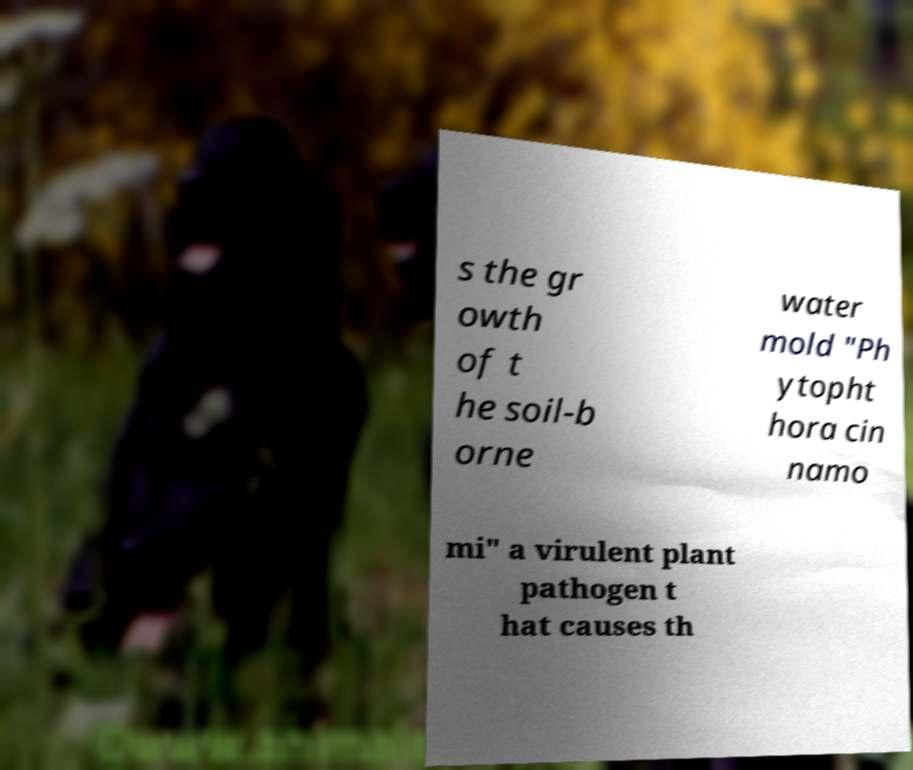Please identify and transcribe the text found in this image. s the gr owth of t he soil-b orne water mold "Ph ytopht hora cin namo mi" a virulent plant pathogen t hat causes th 